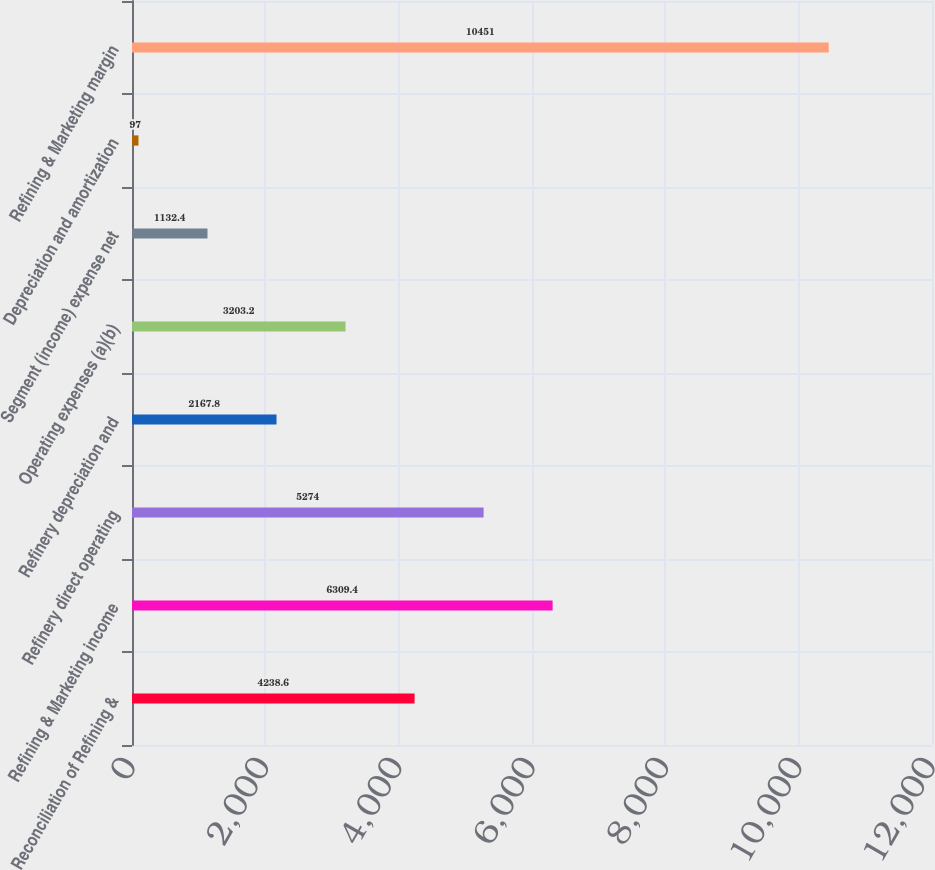Convert chart to OTSL. <chart><loc_0><loc_0><loc_500><loc_500><bar_chart><fcel>Reconciliation of Refining &<fcel>Refining & Marketing income<fcel>Refinery direct operating<fcel>Refinery depreciation and<fcel>Operating expenses (a)(b)<fcel>Segment (income) expense net<fcel>Depreciation and amortization<fcel>Refining & Marketing margin<nl><fcel>4238.6<fcel>6309.4<fcel>5274<fcel>2167.8<fcel>3203.2<fcel>1132.4<fcel>97<fcel>10451<nl></chart> 